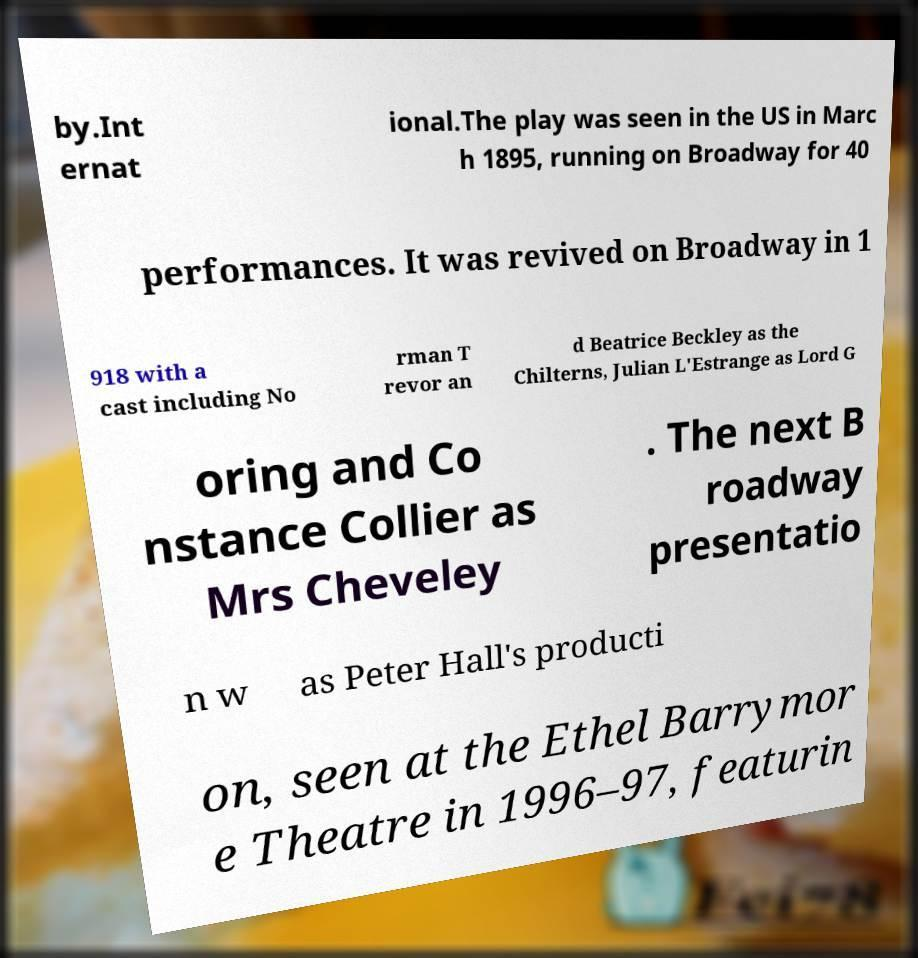Could you assist in decoding the text presented in this image and type it out clearly? by.Int ernat ional.The play was seen in the US in Marc h 1895, running on Broadway for 40 performances. It was revived on Broadway in 1 918 with a cast including No rman T revor an d Beatrice Beckley as the Chilterns, Julian L'Estrange as Lord G oring and Co nstance Collier as Mrs Cheveley . The next B roadway presentatio n w as Peter Hall's producti on, seen at the Ethel Barrymor e Theatre in 1996–97, featurin 